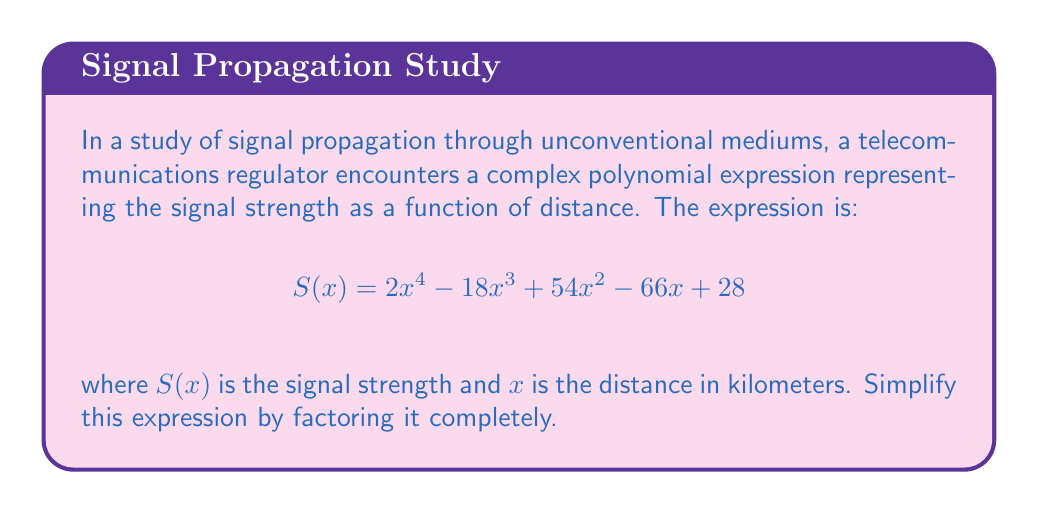Provide a solution to this math problem. To factor this polynomial completely, we'll follow these steps:

1) First, let's check if there's a common factor:
   There's no common factor for all terms, so we proceed to the next step.

2) This is a 4th-degree polynomial, so we'll try to factor it as a product of two quadratic expressions:
   $$(ax^2 + bx + c)(dx^2 + ex + f) = 2x^4 - 18x^3 + 54x^2 - 66x + 28$$

3) We know that $ad = 2$ and $cf = 28$. Possible factor pairs are:
   $(1, 2)$, $(2, 1)$, $(-1, -2)$, $(-2, -1)$
   $(1, 28)$, $(28, 1)$, $(-1, -28)$, $(-28, -1)$
   $(2, 14)$, $(14, 2)$, $(-2, -14)$, $(-14, -2)$
   $(4, 7)$, $(7, 4)$, $(-4, -7)$, $(-7, -4)$

4) After trying different combinations, we find that $(2x^2 - 6x + 2)(x^2 - 6x + 14)$ works.

5) Let's factor these quadratic expressions further:
   For $(2x^2 - 6x + 2)$:
   $2(x^2 - 3x + 1) = 2(x - 1)(x - 2)$

   For $(x^2 - 6x + 14)$:
   This is a perfect square trinomial
   $(x - 3)^2 + 5 = (x - 3)^2 + (\sqrt{5})^2 = (x - 3 + \sqrt{5})(x - 3 - \sqrt{5})$

6) Therefore, the fully factored expression is:
   $$2(x - 1)(x - 2)(x - 3 + \sqrt{5})(x - 3 - \sqrt{5})$$
Answer: $2(x - 1)(x - 2)(x - 3 + \sqrt{5})(x - 3 - \sqrt{5})$ 